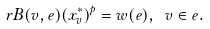Convert formula to latex. <formula><loc_0><loc_0><loc_500><loc_500>r B ( v , e ) ( x _ { v } ^ { * } ) ^ { p } = w ( e ) , \ v \in e .</formula> 